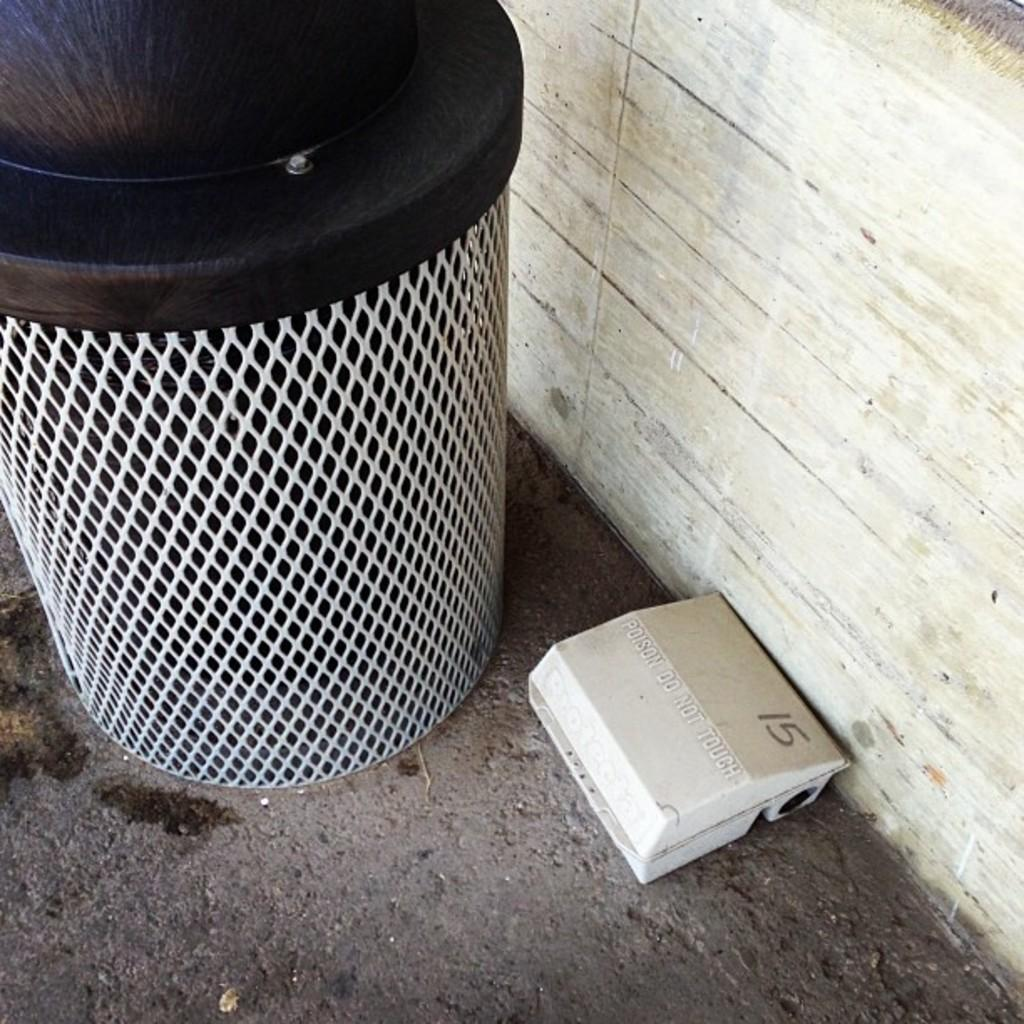What object is present in the image for waste disposal? There is a dustbin in the image. What other object can be seen on the floor in the image? There is a box on the floor in the image. What can be seen in the background of the image? There is a wall in the background of the image. What type of class is being taught in the image? There is no class or teaching activity present in the image. Can you see any roots growing from the wall in the image? There are no roots visible in the image; only a wall is present in the background. 